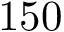<formula> <loc_0><loc_0><loc_500><loc_500>1 5 0</formula> 